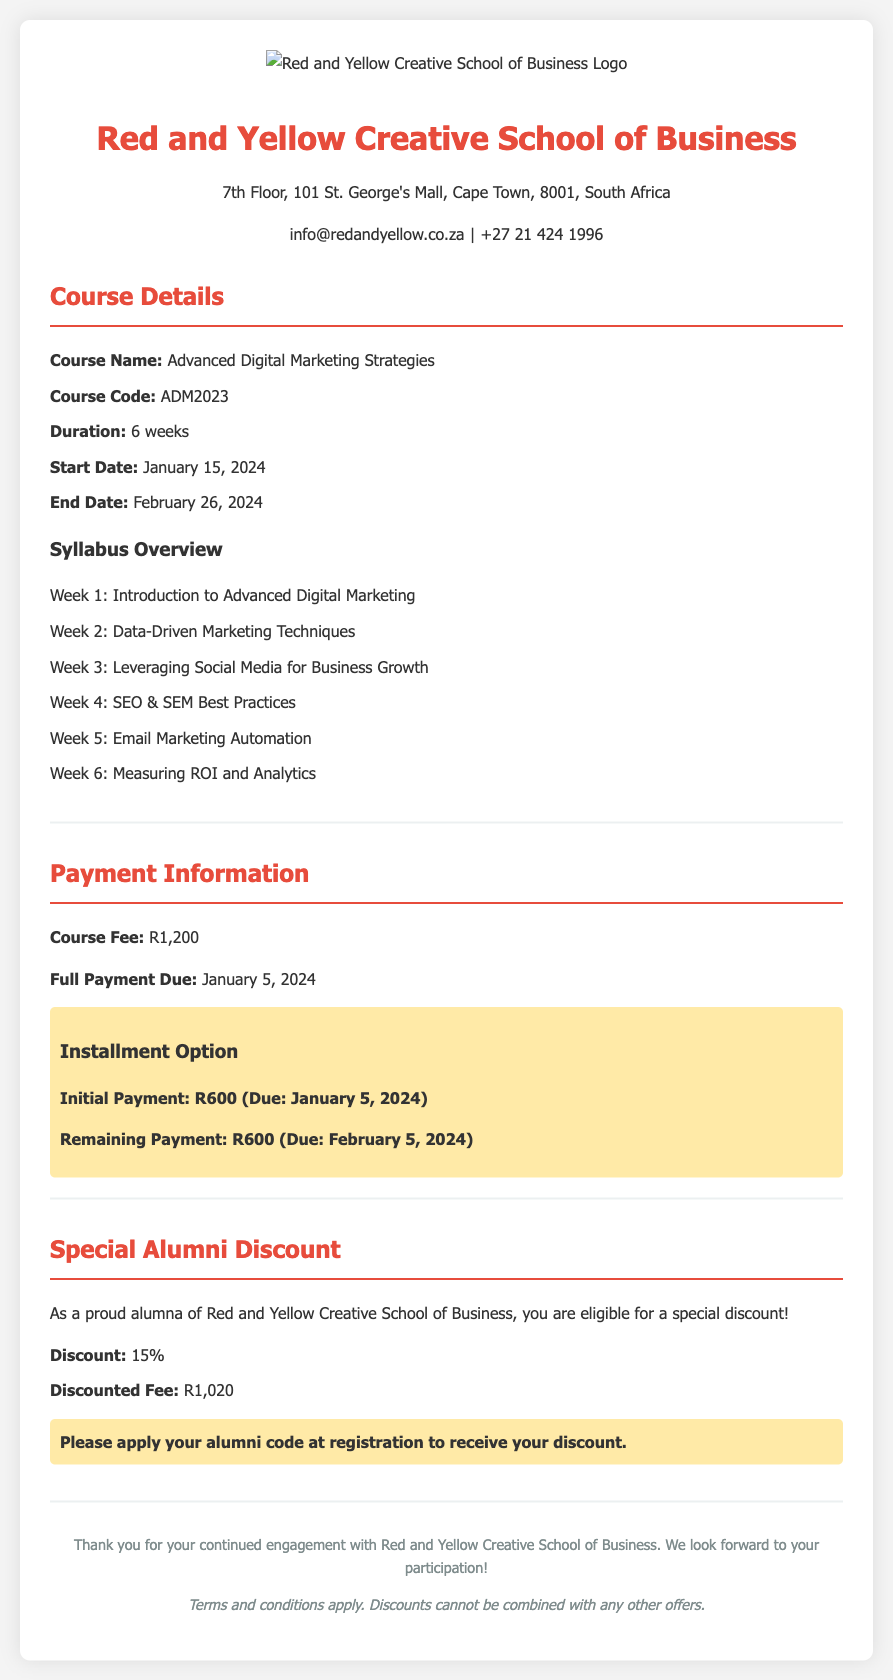What is the course name? The course name is listed in the course details section.
Answer: Advanced Digital Marketing Strategies What is the course fee? The course fee is specified in the payment information section.
Answer: R1,200 What is the start date of the course? The start date is provided in the course details section.
Answer: January 15, 2024 What is the special alumni discount percentage? The discount percentage is found in the special alumni discount section.
Answer: 15% When is the full payment due? The deadline for full payment is outlined in the payment information section.
Answer: January 5, 2024 What are the weeks covered in the syllabus? The syllabus overview lists weekly topics covered in the course.
Answer: 6 weeks What is the discounted fee for alumni? The discounted fee for alumni is mentioned in the special alumni discount section.
Answer: R1,020 What is the final payment due date if opting for installments? The due date for the remaining payment is in the payment information section.
Answer: February 5, 2024 How many weeks does the course last? The duration of the course is specified in the course details section.
Answer: 6 weeks 